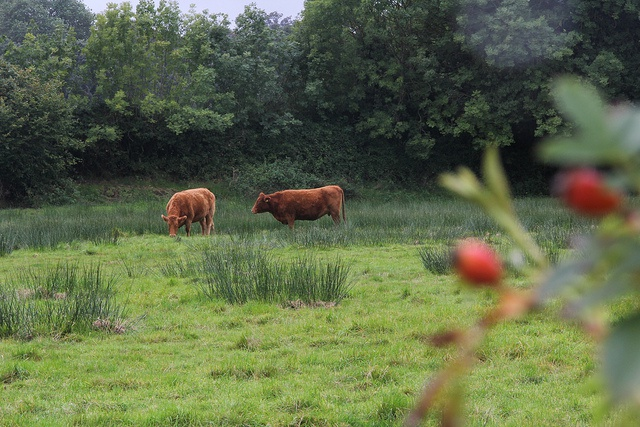Describe the objects in this image and their specific colors. I can see cow in gray, black, maroon, and brown tones and cow in gray, maroon, and brown tones in this image. 